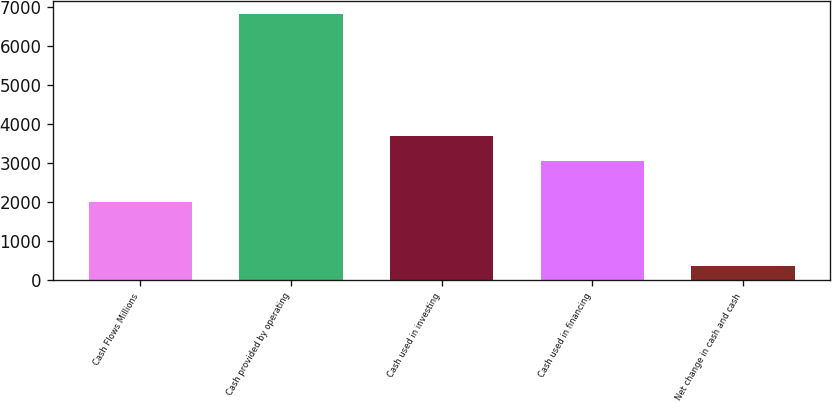Convert chart. <chart><loc_0><loc_0><loc_500><loc_500><bar_chart><fcel>Cash Flows Millions<fcel>Cash provided by operating<fcel>Cash used in investing<fcel>Cash used in financing<fcel>Net change in cash and cash<nl><fcel>2013<fcel>6823<fcel>3694.4<fcel>3049<fcel>369<nl></chart> 